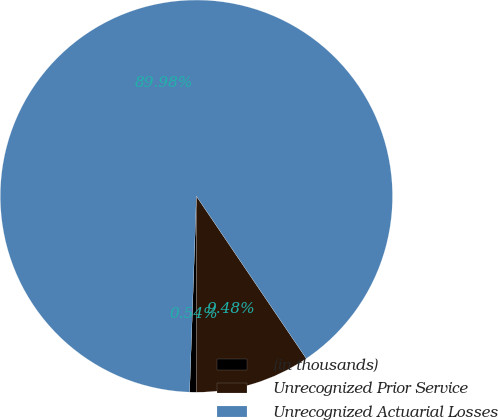Convert chart to OTSL. <chart><loc_0><loc_0><loc_500><loc_500><pie_chart><fcel>(in thousands)<fcel>Unrecognized Prior Service<fcel>Unrecognized Actuarial Losses<nl><fcel>0.54%<fcel>9.48%<fcel>89.98%<nl></chart> 